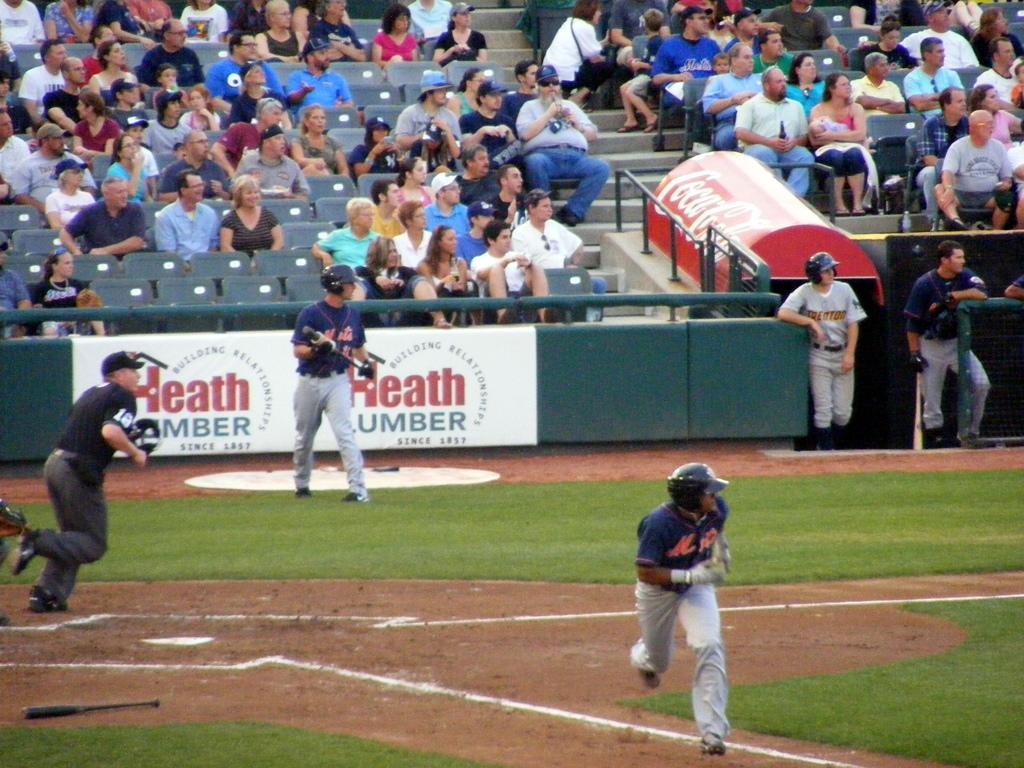<image>
Share a concise interpretation of the image provided. mets player running to first base while another stands in front of banner for heath lumber 